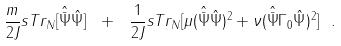<formula> <loc_0><loc_0><loc_500><loc_500>\frac { m } { 2 J } s T r _ { N } [ { \hat { \bar { \Psi } } } { \hat { \Psi } } ] \ + \ \frac { 1 } { 2 J } s T r _ { N } [ \mu ( { \hat { \bar { \Psi } } } { \hat { \Psi } } ) ^ { 2 } + \nu ( { \hat { \bar { \Psi } } } \Gamma _ { 0 } { \hat { \Psi } } ) ^ { 2 } ] \ .</formula> 